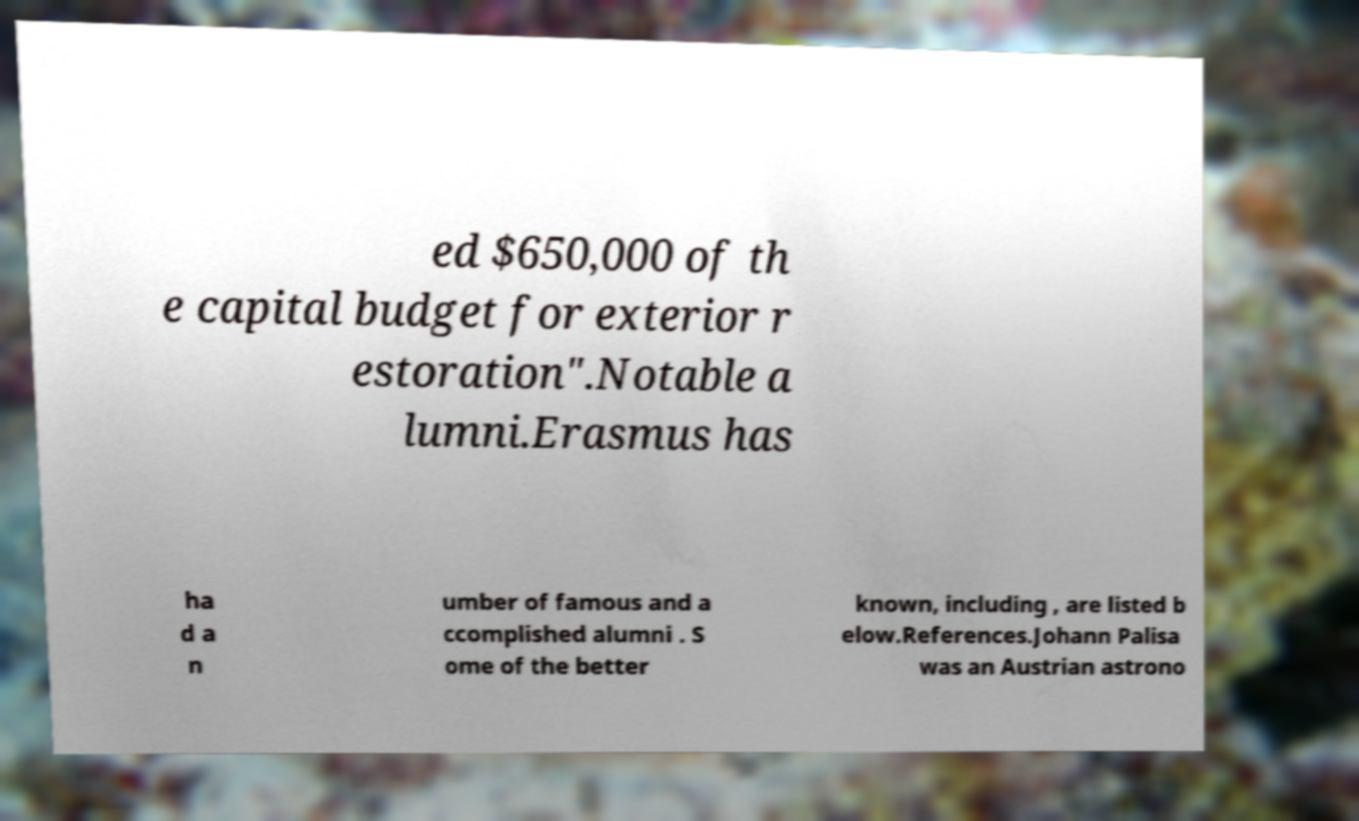What messages or text are displayed in this image? I need them in a readable, typed format. ed $650,000 of th e capital budget for exterior r estoration".Notable a lumni.Erasmus has ha d a n umber of famous and a ccomplished alumni . S ome of the better known, including , are listed b elow.References.Johann Palisa was an Austrian astrono 